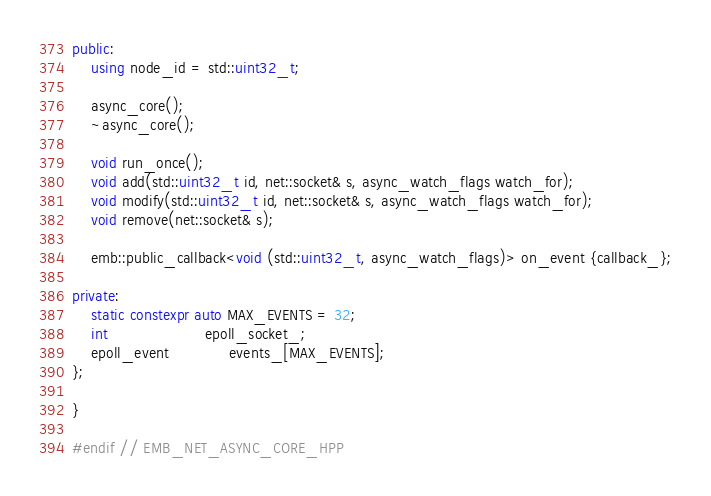Convert code to text. <code><loc_0><loc_0><loc_500><loc_500><_C++_>public:
    using node_id = std::uint32_t;

    async_core();
    ~async_core();

    void run_once();
    void add(std::uint32_t id, net::socket& s, async_watch_flags watch_for);
    void modify(std::uint32_t id, net::socket& s, async_watch_flags watch_for);
    void remove(net::socket& s);

    emb::public_callback<void (std::uint32_t, async_watch_flags)> on_event {callback_};

private:
    static constexpr auto MAX_EVENTS = 32;
    int                     epoll_socket_;
    epoll_event             events_[MAX_EVENTS];
};

}

#endif // EMB_NET_ASYNC_CORE_HPP</code> 